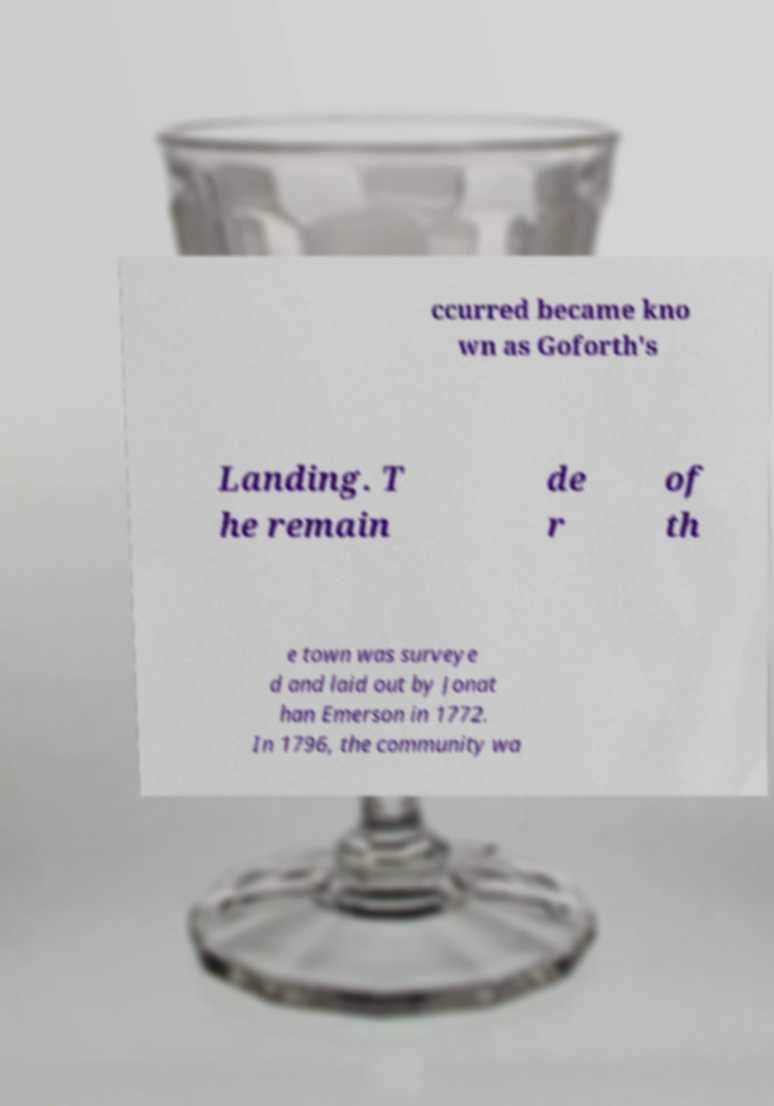Can you accurately transcribe the text from the provided image for me? ccurred became kno wn as Goforth's Landing. T he remain de r of th e town was surveye d and laid out by Jonat han Emerson in 1772. In 1796, the community wa 